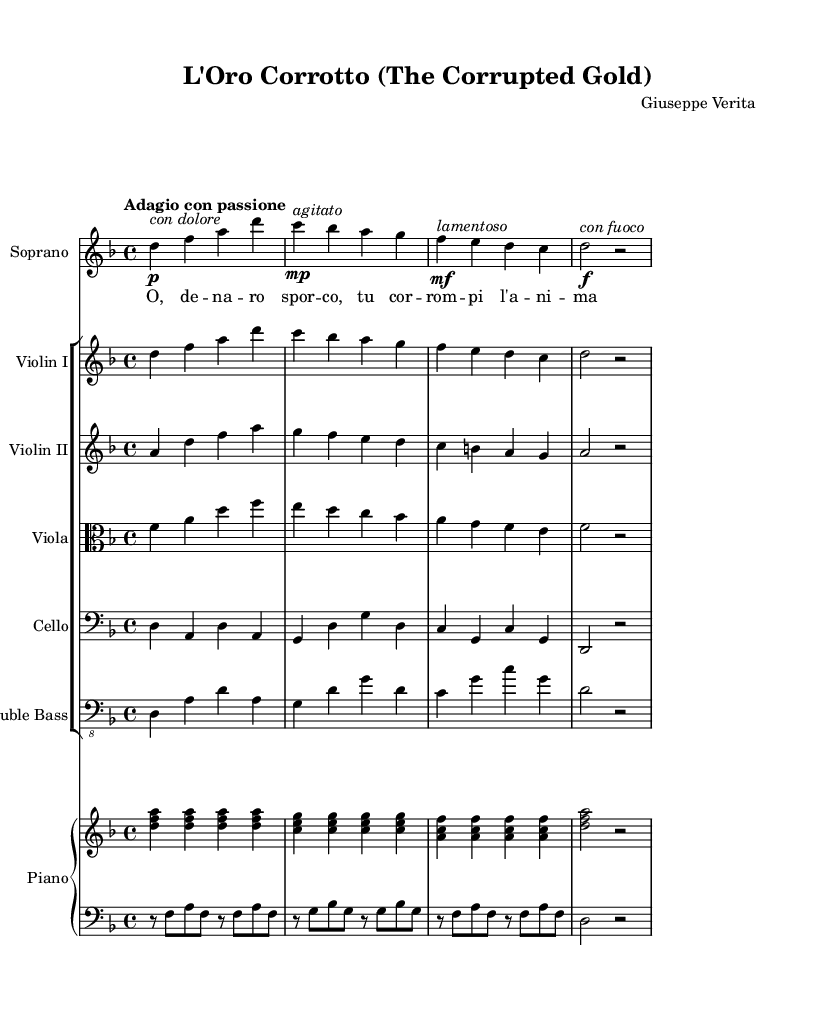What is the key signature of this music? The key signature is D minor, which has one flat (B flat).
Answer: D minor What is the time signature of this piece? The time signature is 4/4, indicating four beats per measure.
Answer: 4/4 What is the tempo marking for this composition? The tempo marking is "Adagio con passione," indicating a slow pace with passion.
Answer: Adagio con passione Which voice part has the highest pitch range? The Soprano voice part is indicated to have the highest pitch range, as it is written in the treble clef and occupies a higher octave compared to the other instruments.
Answer: Soprano What is the dynamic marking at measure three for the soprano voice? The dynamic marking at measure three is "mf," indicating a moderately loud dynamic.
Answer: mf How many instruments are included in this score? The score includes a total of six instruments: Soprano, Violin I, Violin II, Viola, Cello, Double Bass, and a Piano duo.
Answer: Six instruments What theme is expressed through the lyrics of this piece? The lyrics express themes of corruption and moral decay, suggesting a lamentation on the impact of financial corruption.
Answer: Corruption 